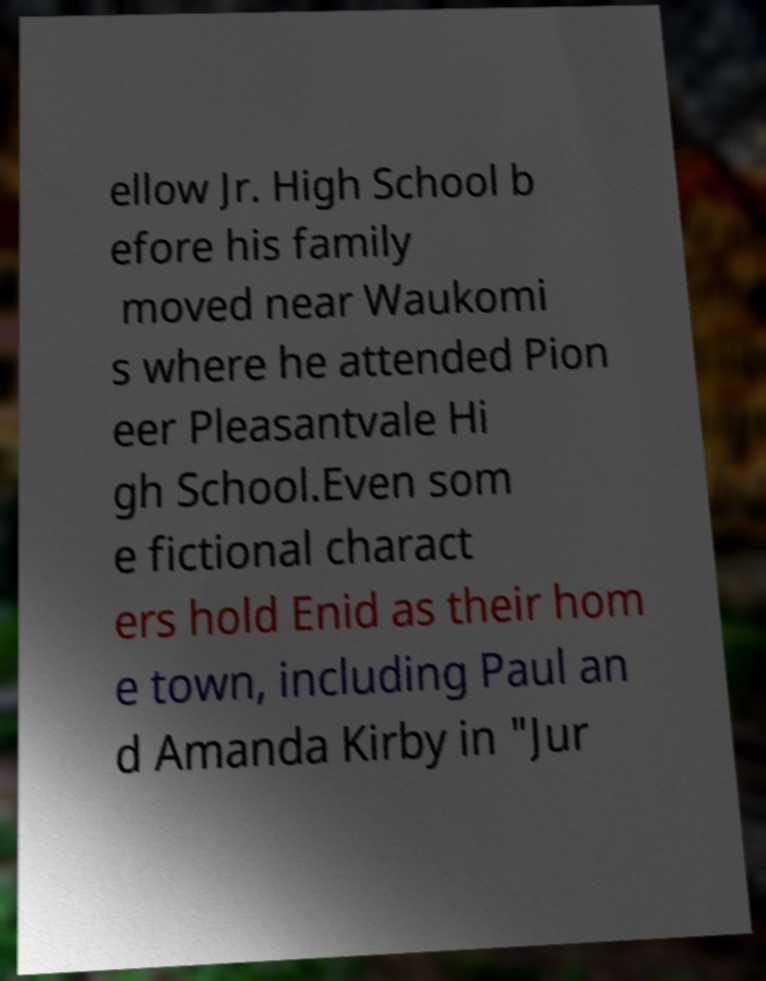There's text embedded in this image that I need extracted. Can you transcribe it verbatim? ellow Jr. High School b efore his family moved near Waukomi s where he attended Pion eer Pleasantvale Hi gh School.Even som e fictional charact ers hold Enid as their hom e town, including Paul an d Amanda Kirby in "Jur 